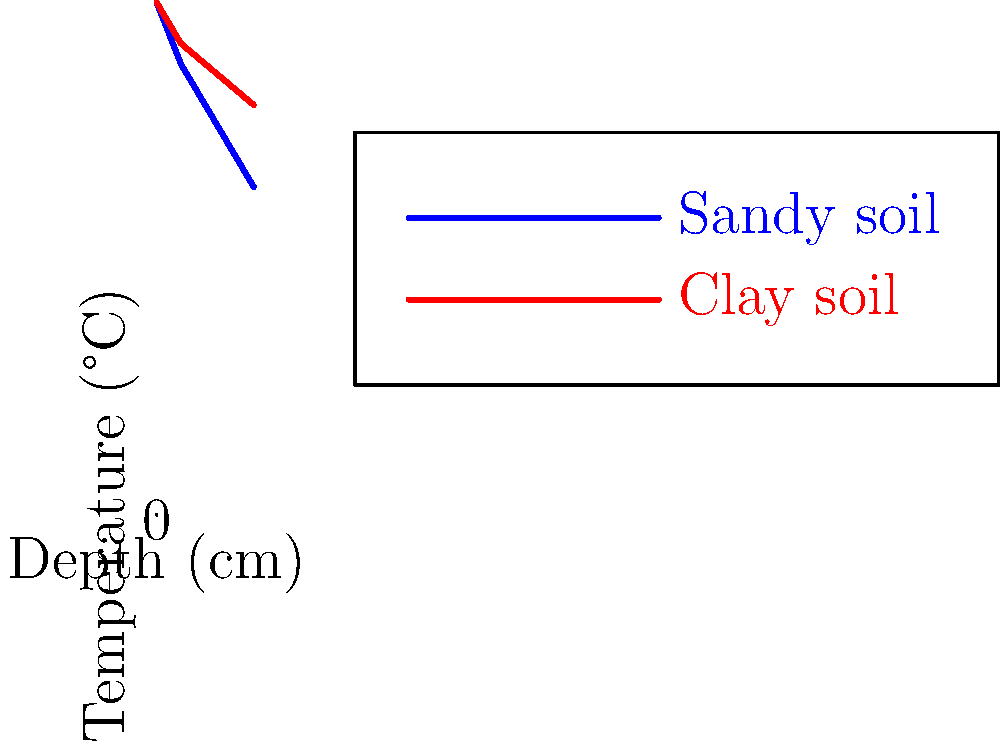Based on the temperature gradient graphs for sandy and clay soils, which soil type would you expect to have a higher thermal conductivity? Explain your reasoning using the concepts of heat transfer and soil properties. To determine which soil type has a higher thermal conductivity, we need to analyze the temperature gradients shown in the graph:

1. Observe the slopes of the temperature curves:
   - Sandy soil (blue line) shows a steeper gradient
   - Clay soil (red line) shows a more gradual gradient

2. Understand the relationship between temperature gradient and thermal conductivity:
   - Thermal conductivity ($k$) is related to heat flux ($q$) and temperature gradient ($\frac{dT}{dx}$) by Fourier's law:
     $q = -k \frac{dT}{dx}$

3. Apply this concept to the soil types:
   - For the same heat flux, a material with higher thermal conductivity will have a smaller temperature gradient
   - Conversely, a steeper temperature gradient indicates lower thermal conductivity

4. Compare the gradients:
   - Sandy soil has a steeper gradient, implying lower thermal conductivity
   - Clay soil has a more gradual gradient, suggesting higher thermal conductivity

5. Consider soil properties:
   - Clay particles are smaller and pack more tightly, allowing better heat transfer
   - Sandy soil has larger particles with more air pockets, reducing heat transfer

Therefore, based on the temperature gradients and soil properties, clay soil would be expected to have a higher thermal conductivity.
Answer: Clay soil 